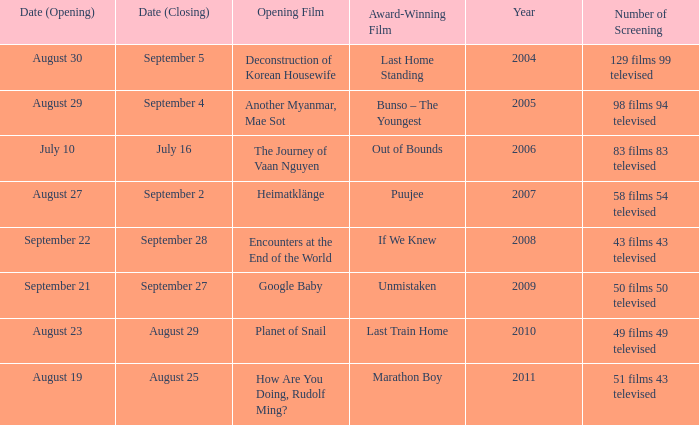Which award-winning film has a screening number of 50 films 50 televised? Unmistaken. 